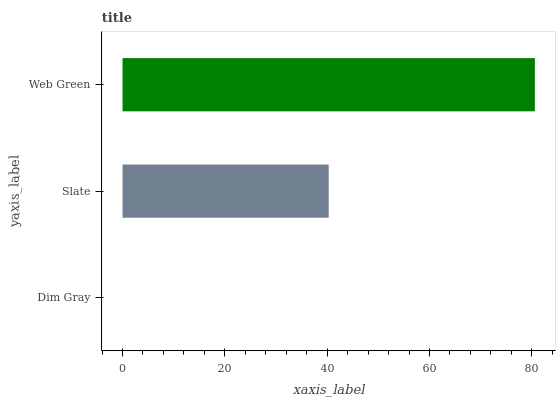Is Dim Gray the minimum?
Answer yes or no. Yes. Is Web Green the maximum?
Answer yes or no. Yes. Is Slate the minimum?
Answer yes or no. No. Is Slate the maximum?
Answer yes or no. No. Is Slate greater than Dim Gray?
Answer yes or no. Yes. Is Dim Gray less than Slate?
Answer yes or no. Yes. Is Dim Gray greater than Slate?
Answer yes or no. No. Is Slate less than Dim Gray?
Answer yes or no. No. Is Slate the high median?
Answer yes or no. Yes. Is Slate the low median?
Answer yes or no. Yes. Is Dim Gray the high median?
Answer yes or no. No. Is Web Green the low median?
Answer yes or no. No. 